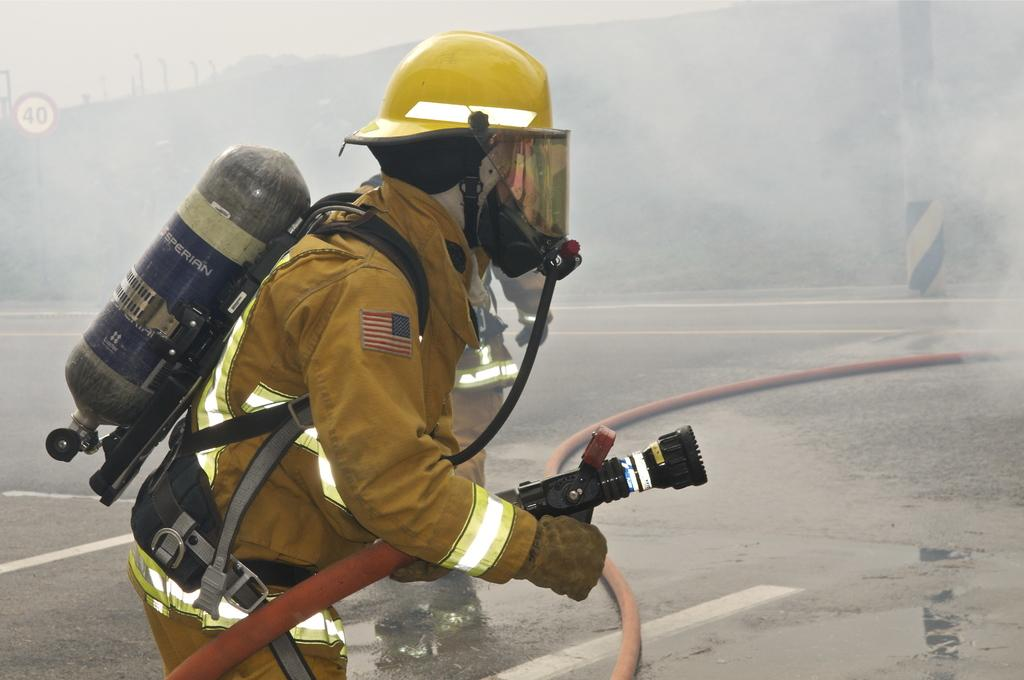What are the men in the image doing? The men are standing on the road. What are the men wearing on their faces? The men are wearing masks. What are the cylinders attached to the men's backs? The men have cylinders attached to their backs. What can be seen in the background of the image? There are buildings, sign boards, and the sky visible in the background of the image. What type of door can be seen in the image? There is no door present in the image; it features men standing on the road with masks and cylinders attached to their backs. Can you tell me how many goats are visible in the image? There are no goats present in the image. 